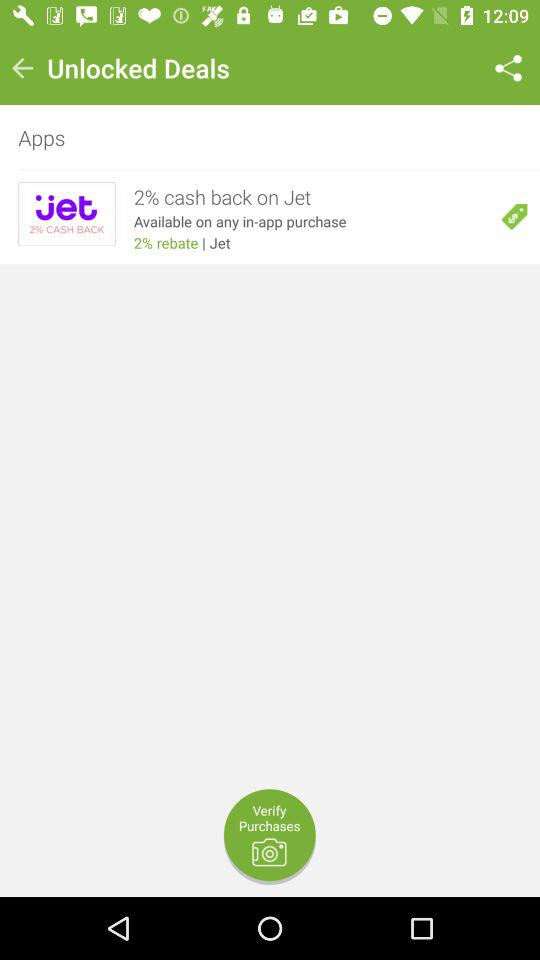How much cash back is available on Jet purchases?
Answer the question using a single word or phrase. 2% 